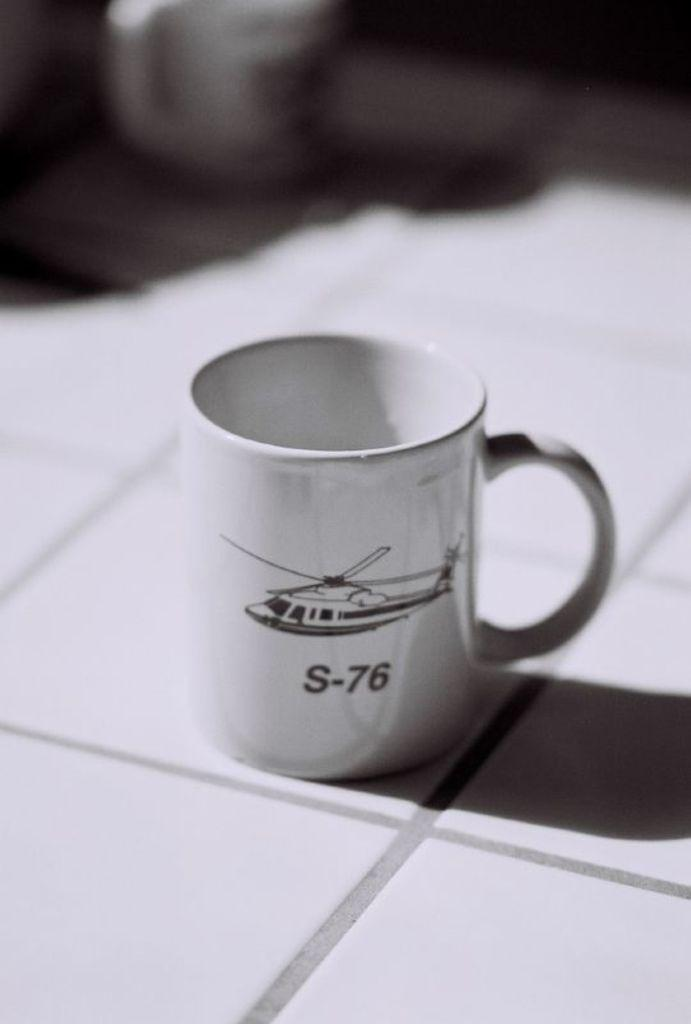<image>
Create a compact narrative representing the image presented. A mug with a helicopter and S-76 below it sits on a tiled surface. 